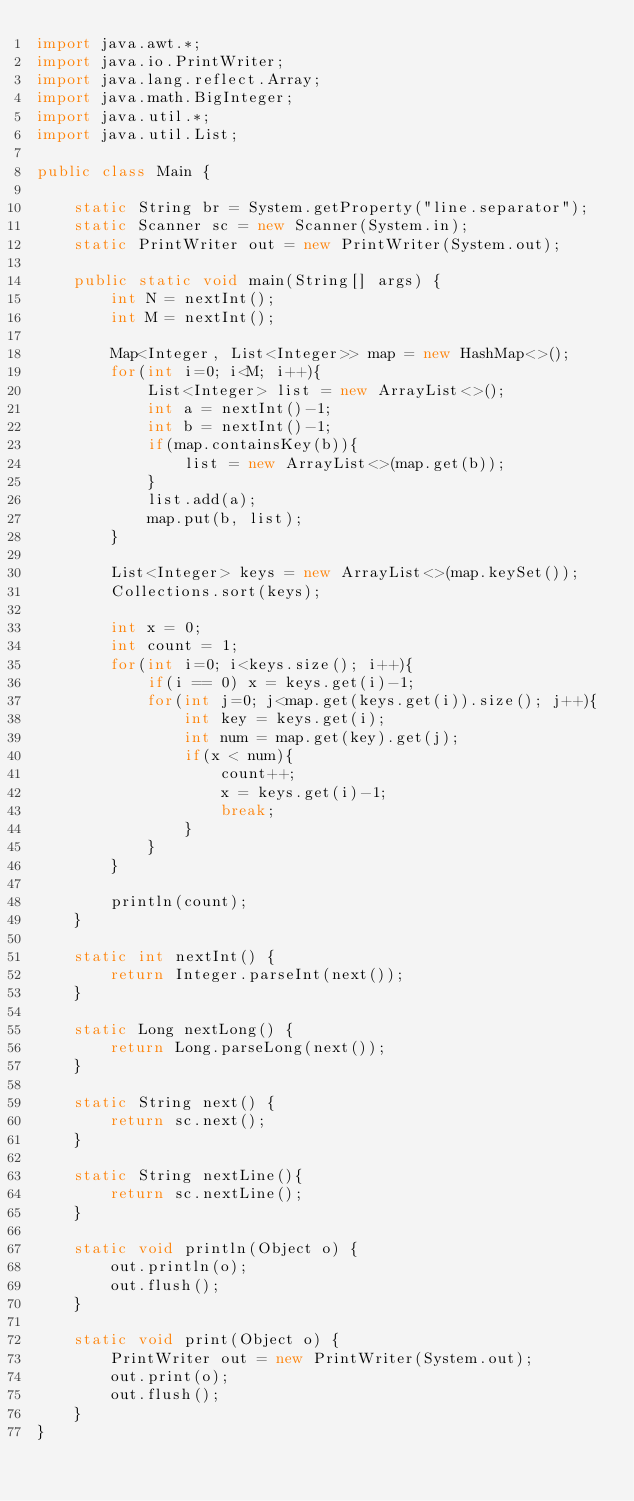Convert code to text. <code><loc_0><loc_0><loc_500><loc_500><_Java_>import java.awt.*;
import java.io.PrintWriter;
import java.lang.reflect.Array;
import java.math.BigInteger;
import java.util.*;
import java.util.List;

public class Main {

    static String br = System.getProperty("line.separator");
    static Scanner sc = new Scanner(System.in);
    static PrintWriter out = new PrintWriter(System.out);

    public static void main(String[] args) {
        int N = nextInt();
        int M = nextInt();

        Map<Integer, List<Integer>> map = new HashMap<>();
        for(int i=0; i<M; i++){
            List<Integer> list = new ArrayList<>();
            int a = nextInt()-1;
            int b = nextInt()-1;
            if(map.containsKey(b)){
                list = new ArrayList<>(map.get(b));
            }
            list.add(a);
            map.put(b, list);
        }

        List<Integer> keys = new ArrayList<>(map.keySet());
        Collections.sort(keys);

        int x = 0;
        int count = 1;
        for(int i=0; i<keys.size(); i++){
            if(i == 0) x = keys.get(i)-1;
            for(int j=0; j<map.get(keys.get(i)).size(); j++){
                int key = keys.get(i);
                int num = map.get(key).get(j);
                if(x < num){
                    count++;
                    x = keys.get(i)-1;
                    break;
                }
            }
        }

        println(count);
    }

    static int nextInt() {
        return Integer.parseInt(next());
    }

    static Long nextLong() {
        return Long.parseLong(next());
    }

    static String next() {
        return sc.next();
    }

    static String nextLine(){
        return sc.nextLine();
    }

    static void println(Object o) {
        out.println(o);
        out.flush();
    }

    static void print(Object o) {
        PrintWriter out = new PrintWriter(System.out);
        out.print(o);
        out.flush();
    }
}
</code> 